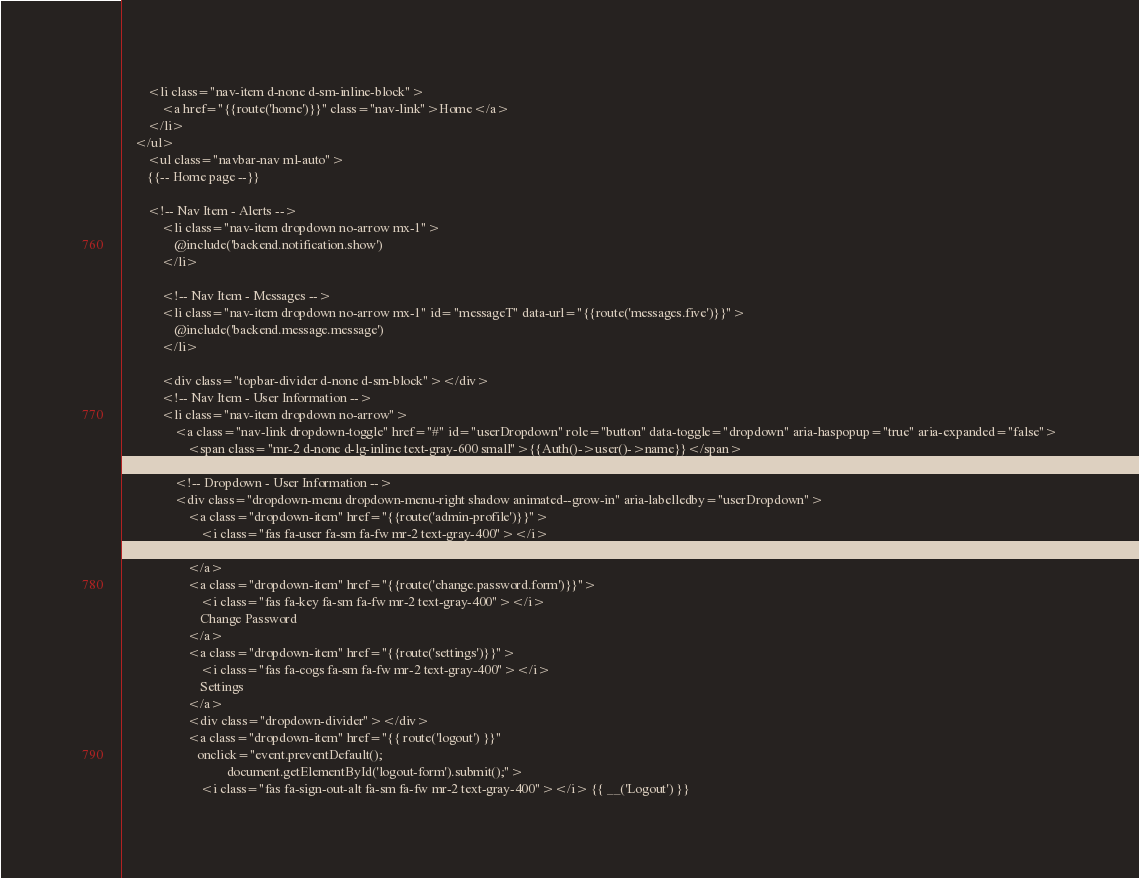Convert code to text. <code><loc_0><loc_0><loc_500><loc_500><_PHP_>        <li class="nav-item d-none d-sm-inline-block">
            <a href="{{route('home')}}" class="nav-link">Home</a>
        </li>
    </ul>
        <ul class="navbar-nav ml-auto">
        {{-- Home page --}}

        <!-- Nav Item - Alerts -->
            <li class="nav-item dropdown no-arrow mx-1">
                @include('backend.notification.show')
            </li>

            <!-- Nav Item - Messages -->
            <li class="nav-item dropdown no-arrow mx-1" id="messageT" data-url="{{route('messages.five')}}">
                @include('backend.message.message')
            </li>

            <div class="topbar-divider d-none d-sm-block"></div>
            <!-- Nav Item - User Information -->
            <li class="nav-item dropdown no-arrow">
                <a class="nav-link dropdown-toggle" href="#" id="userDropdown" role="button" data-toggle="dropdown" aria-haspopup="true" aria-expanded="false">
                    <span class="mr-2 d-none d-lg-inline text-gray-600 small">{{Auth()->user()->name}}</span>
                </a>
                <!-- Dropdown - User Information -->
                <div class="dropdown-menu dropdown-menu-right shadow animated--grow-in" aria-labelledby="userDropdown">
                    <a class="dropdown-item" href="{{route('admin-profile')}}">
                        <i class="fas fa-user fa-sm fa-fw mr-2 text-gray-400"></i>
                        Profile
                    </a>
                    <a class="dropdown-item" href="{{route('change.password.form')}}">
                        <i class="fas fa-key fa-sm fa-fw mr-2 text-gray-400"></i>
                        Change Password
                    </a>
                    <a class="dropdown-item" href="{{route('settings')}}">
                        <i class="fas fa-cogs fa-sm fa-fw mr-2 text-gray-400"></i>
                        Settings
                    </a>
                    <div class="dropdown-divider"></div>
                    <a class="dropdown-item" href="{{ route('logout') }}"
                       onclick="event.preventDefault();
                                document.getElementById('logout-form').submit();">
                        <i class="fas fa-sign-out-alt fa-sm fa-fw mr-2 text-gray-400"></i> {{ __('Logout') }}</code> 